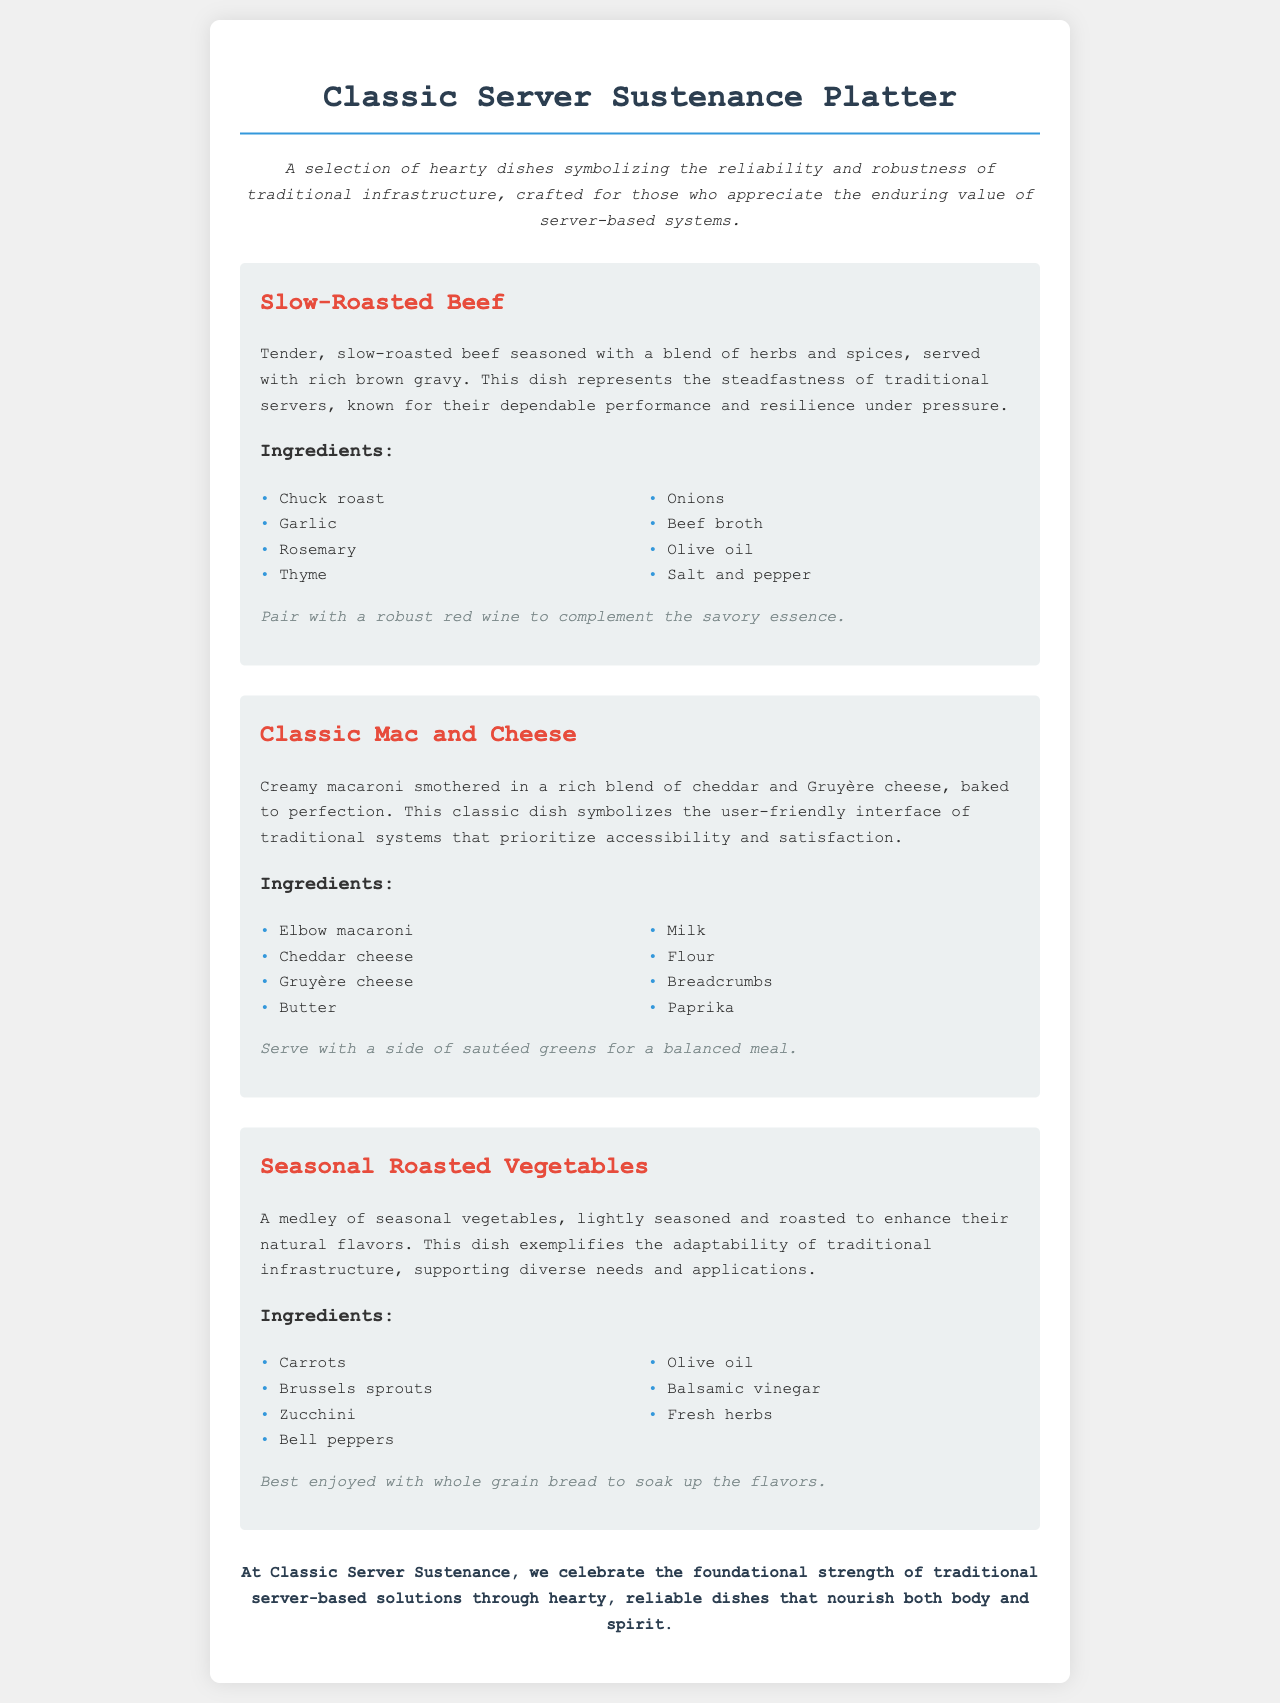What is the name of the platter? The document identifies the platter as "Classic Server Sustenance Platter."
Answer: Classic Server Sustenance Platter What type of dish is Slow-Roasted Beef? The description states that Slow-Roasted Beef is "tender, slow-roasted beef seasoned with a blend of herbs and spices."
Answer: Tender, slow-roasted beef How many ingredients are listed for Classic Mac and Cheese? The ingredients section for Classic Mac and Cheese includes eight items.
Answer: Eight Which cheese is included in the Classic Mac and Cheese? The document lists both Cheddar cheese and Gruyère cheese as ingredients.
Answer: Cheddar and Gruyère cheese What does Seasonal Roasted Vegetables exemplify? The description explains that Seasonal Roasted Vegetables exemplifies "the adaptability of traditional infrastructure."
Answer: Adaptability of traditional infrastructure What accompanying suggestion is provided for Slow-Roasted Beef? The service suggestion suggests pairing it with "a robust red wine."
Answer: Robust red wine Which dish represents user-friendly interface? The description mentions that Classic Mac and Cheese symbolizes "the user-friendly interface of traditional systems."
Answer: Classic Mac and Cheese What kind of vegetables are included in the Seasonal Roasted Vegetables? The dish includes a medley of seasonal vegetables like carrots, Brussels sprouts, and zucchini.
Answer: Carrots, Brussels sprouts, and zucchini What is the main theme of the Classic Server Sustenance Platter? The description emphasizes the "reliability and robustness of traditional infrastructure."
Answer: Reliability and robustness of traditional infrastructure 